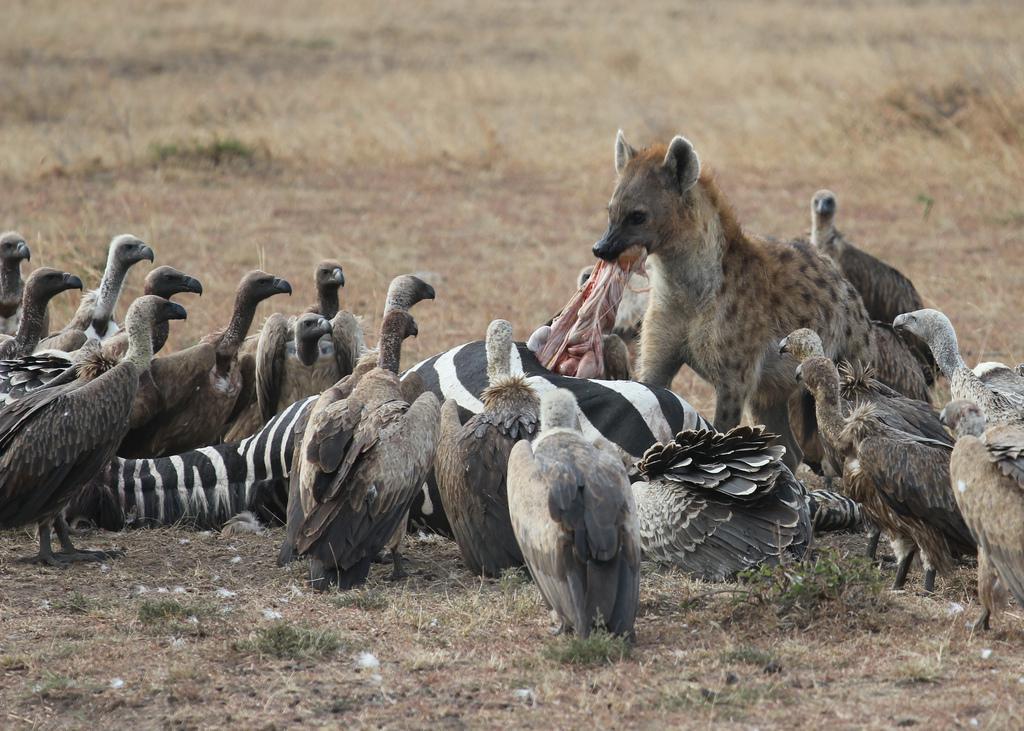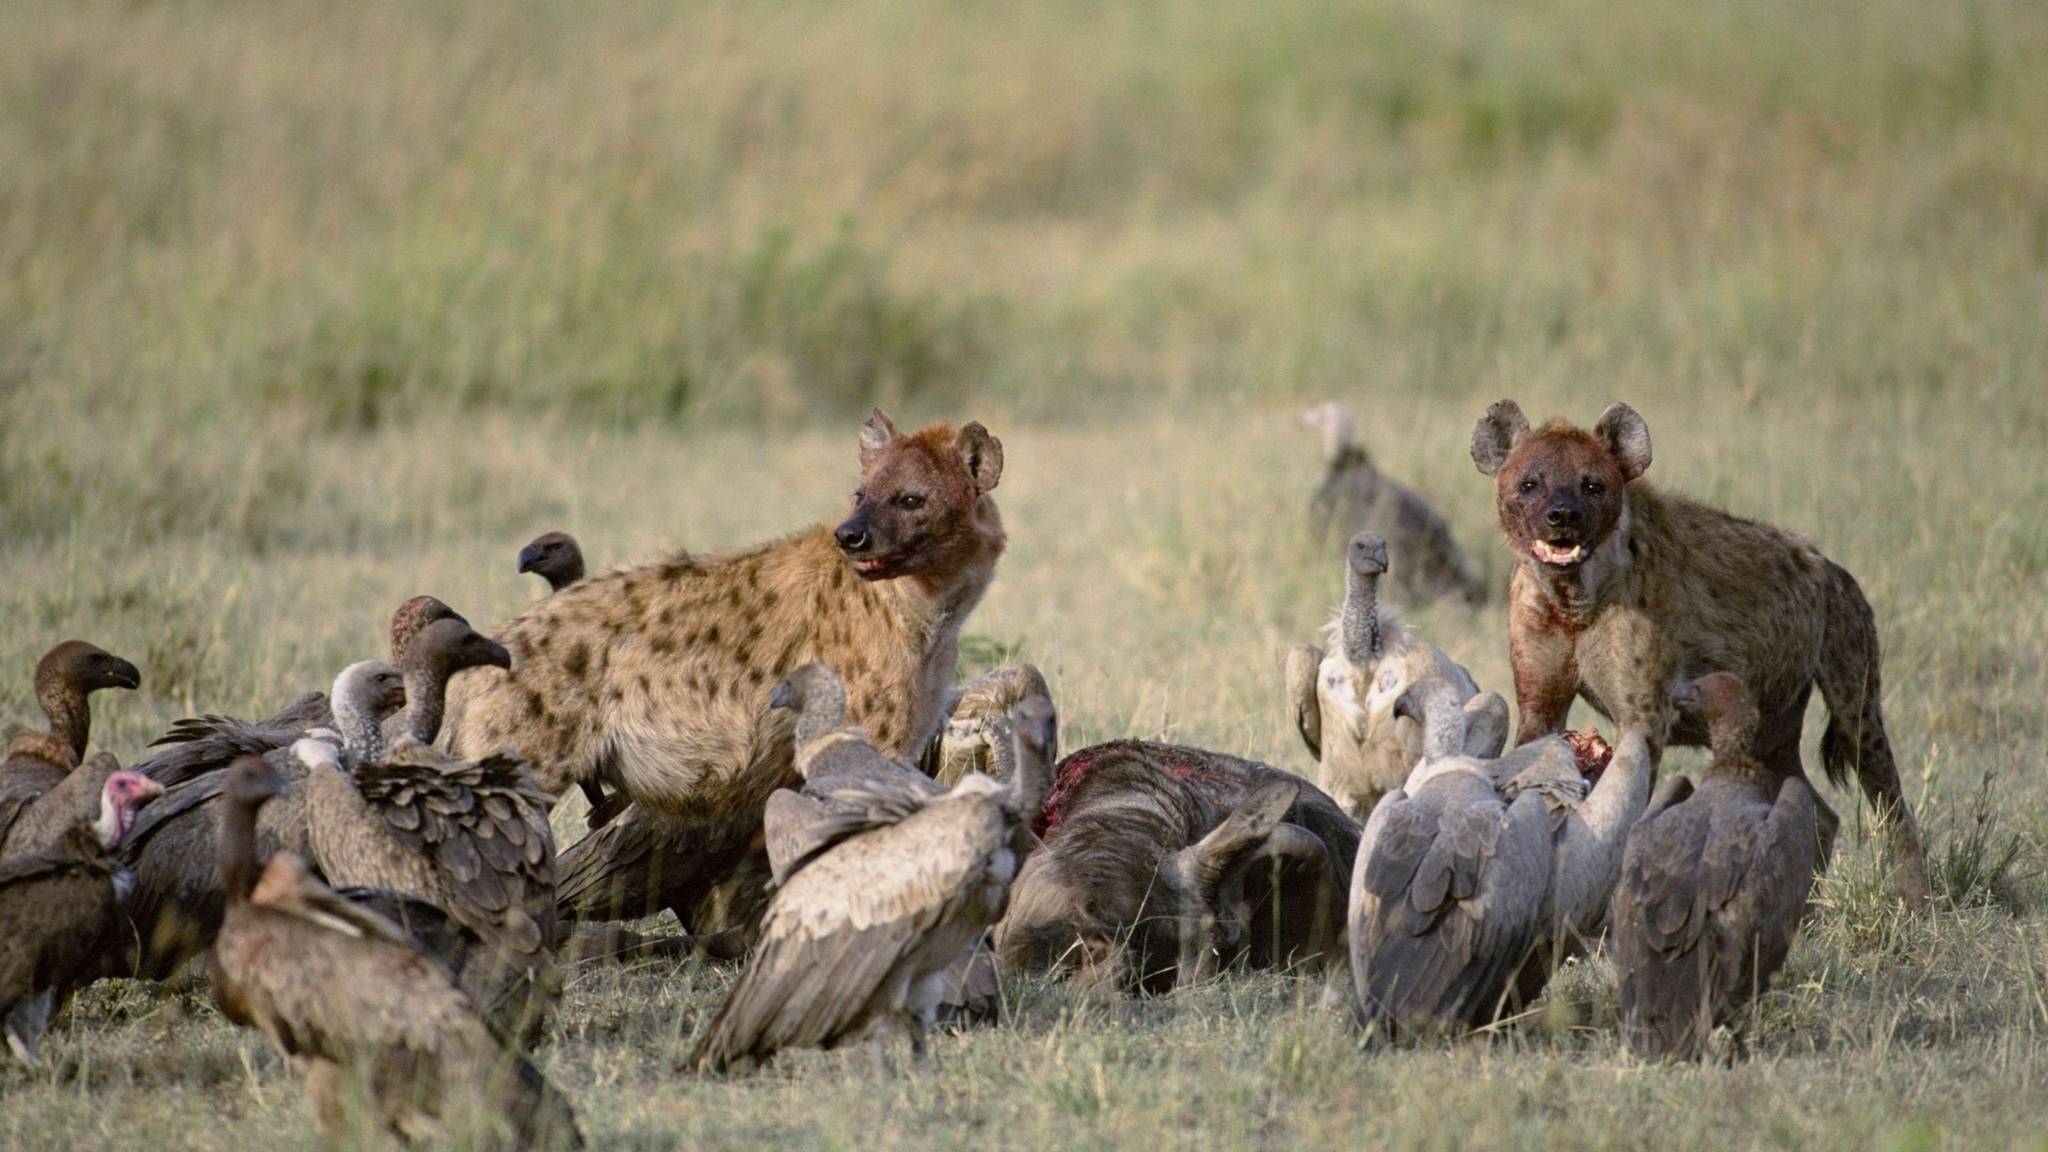The first image is the image on the left, the second image is the image on the right. Analyze the images presented: Is the assertion "In one of the images, the animals are obviously feasting on zebra." valid? Answer yes or no. Yes. 